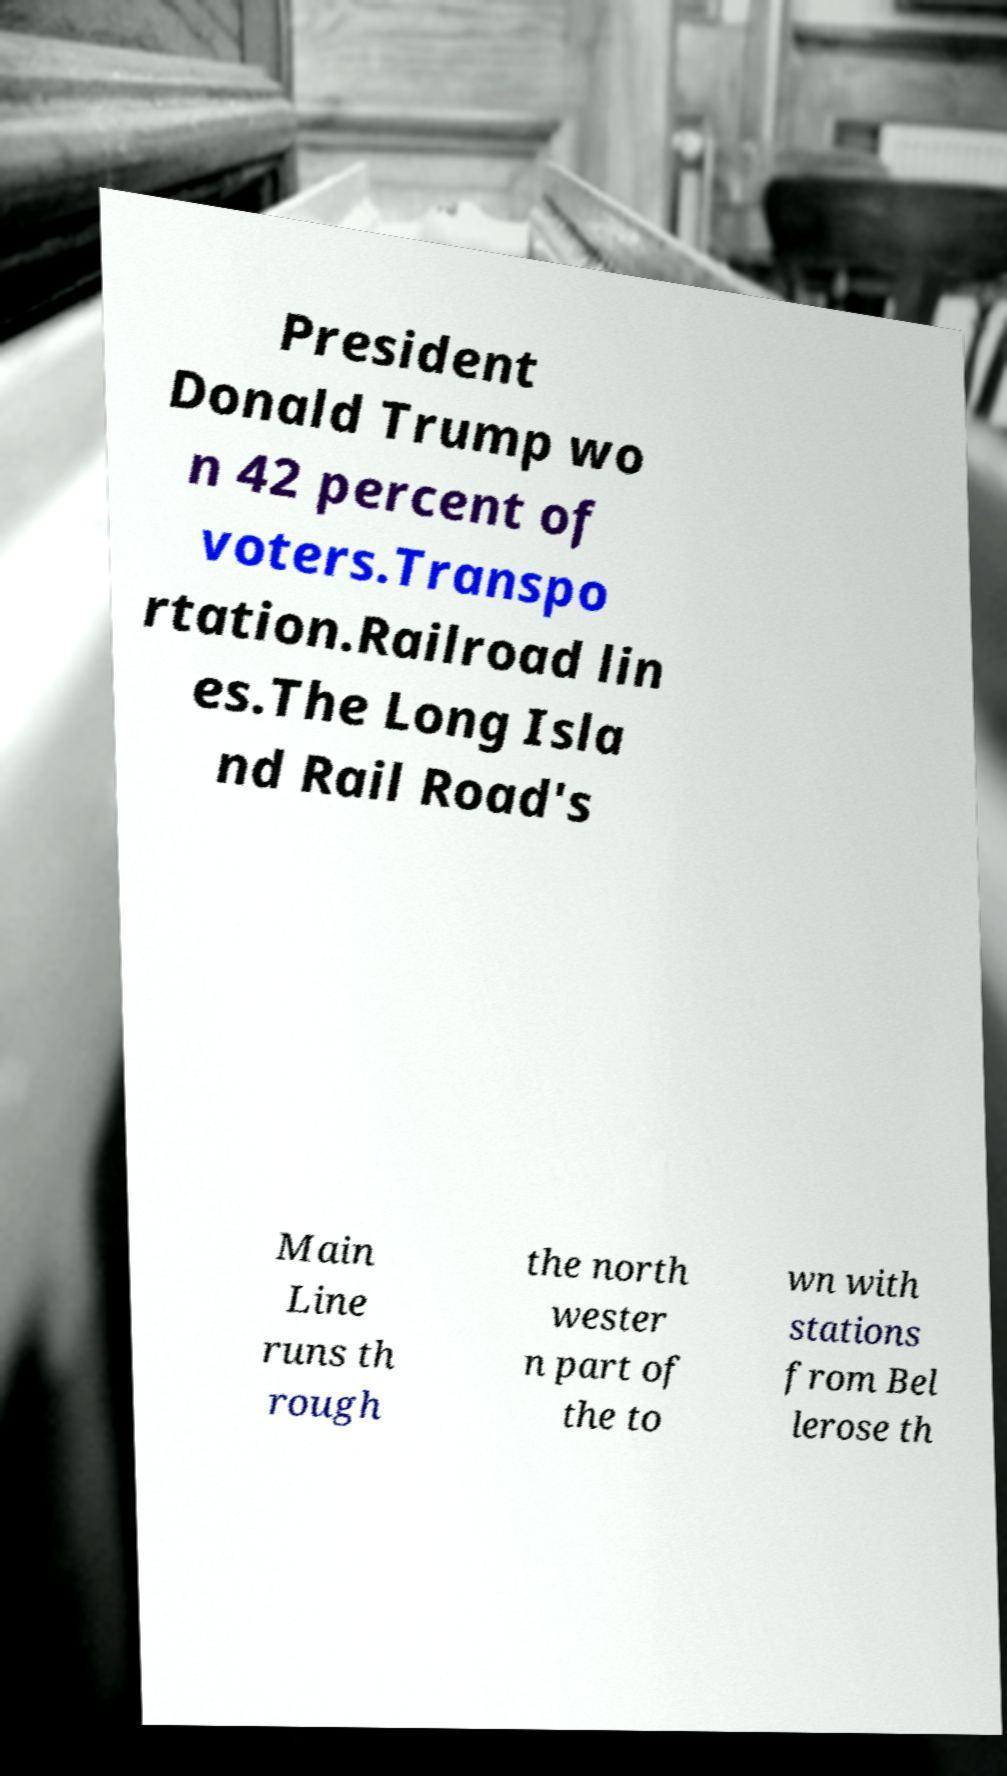Please identify and transcribe the text found in this image. President Donald Trump wo n 42 percent of voters.Transpo rtation.Railroad lin es.The Long Isla nd Rail Road's Main Line runs th rough the north wester n part of the to wn with stations from Bel lerose th 